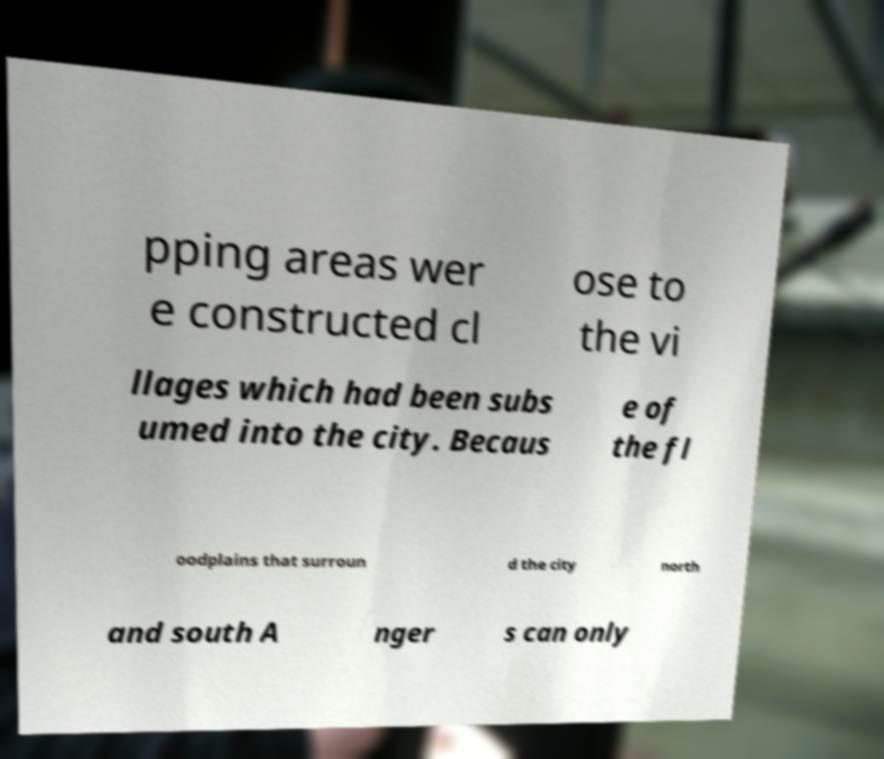Please read and relay the text visible in this image. What does it say? pping areas wer e constructed cl ose to the vi llages which had been subs umed into the city. Becaus e of the fl oodplains that surroun d the city north and south A nger s can only 